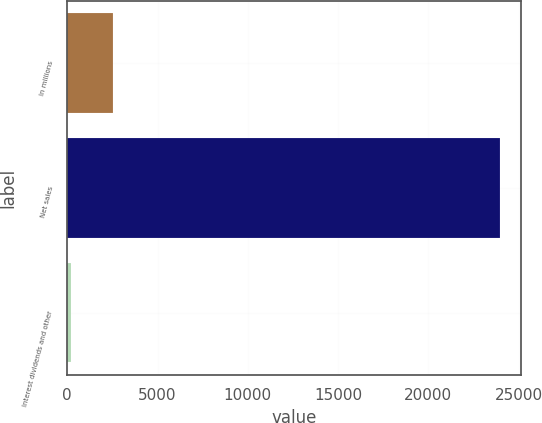Convert chart. <chart><loc_0><loc_0><loc_500><loc_500><bar_chart><fcel>In millions<fcel>Net sales<fcel>Interest dividends and other<nl><fcel>2555.9<fcel>23939<fcel>180<nl></chart> 